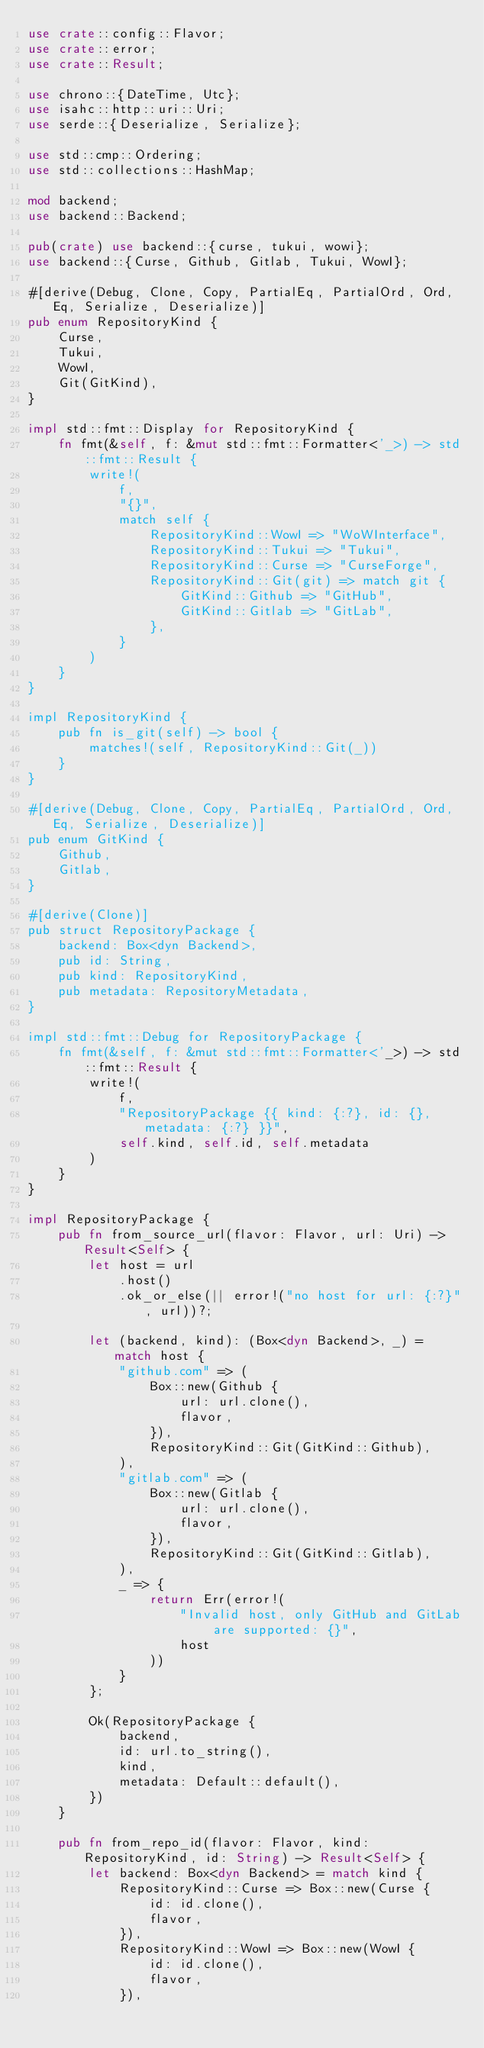Convert code to text. <code><loc_0><loc_0><loc_500><loc_500><_Rust_>use crate::config::Flavor;
use crate::error;
use crate::Result;

use chrono::{DateTime, Utc};
use isahc::http::uri::Uri;
use serde::{Deserialize, Serialize};

use std::cmp::Ordering;
use std::collections::HashMap;

mod backend;
use backend::Backend;

pub(crate) use backend::{curse, tukui, wowi};
use backend::{Curse, Github, Gitlab, Tukui, WowI};

#[derive(Debug, Clone, Copy, PartialEq, PartialOrd, Ord, Eq, Serialize, Deserialize)]
pub enum RepositoryKind {
    Curse,
    Tukui,
    WowI,
    Git(GitKind),
}

impl std::fmt::Display for RepositoryKind {
    fn fmt(&self, f: &mut std::fmt::Formatter<'_>) -> std::fmt::Result {
        write!(
            f,
            "{}",
            match self {
                RepositoryKind::WowI => "WoWInterface",
                RepositoryKind::Tukui => "Tukui",
                RepositoryKind::Curse => "CurseForge",
                RepositoryKind::Git(git) => match git {
                    GitKind::Github => "GitHub",
                    GitKind::Gitlab => "GitLab",
                },
            }
        )
    }
}

impl RepositoryKind {
    pub fn is_git(self) -> bool {
        matches!(self, RepositoryKind::Git(_))
    }
}

#[derive(Debug, Clone, Copy, PartialEq, PartialOrd, Ord, Eq, Serialize, Deserialize)]
pub enum GitKind {
    Github,
    Gitlab,
}

#[derive(Clone)]
pub struct RepositoryPackage {
    backend: Box<dyn Backend>,
    pub id: String,
    pub kind: RepositoryKind,
    pub metadata: RepositoryMetadata,
}

impl std::fmt::Debug for RepositoryPackage {
    fn fmt(&self, f: &mut std::fmt::Formatter<'_>) -> std::fmt::Result {
        write!(
            f,
            "RepositoryPackage {{ kind: {:?}, id: {}, metadata: {:?} }}",
            self.kind, self.id, self.metadata
        )
    }
}

impl RepositoryPackage {
    pub fn from_source_url(flavor: Flavor, url: Uri) -> Result<Self> {
        let host = url
            .host()
            .ok_or_else(|| error!("no host for url: {:?}", url))?;

        let (backend, kind): (Box<dyn Backend>, _) = match host {
            "github.com" => (
                Box::new(Github {
                    url: url.clone(),
                    flavor,
                }),
                RepositoryKind::Git(GitKind::Github),
            ),
            "gitlab.com" => (
                Box::new(Gitlab {
                    url: url.clone(),
                    flavor,
                }),
                RepositoryKind::Git(GitKind::Gitlab),
            ),
            _ => {
                return Err(error!(
                    "Invalid host, only GitHub and GitLab are supported: {}",
                    host
                ))
            }
        };

        Ok(RepositoryPackage {
            backend,
            id: url.to_string(),
            kind,
            metadata: Default::default(),
        })
    }

    pub fn from_repo_id(flavor: Flavor, kind: RepositoryKind, id: String) -> Result<Self> {
        let backend: Box<dyn Backend> = match kind {
            RepositoryKind::Curse => Box::new(Curse {
                id: id.clone(),
                flavor,
            }),
            RepositoryKind::WowI => Box::new(WowI {
                id: id.clone(),
                flavor,
            }),</code> 